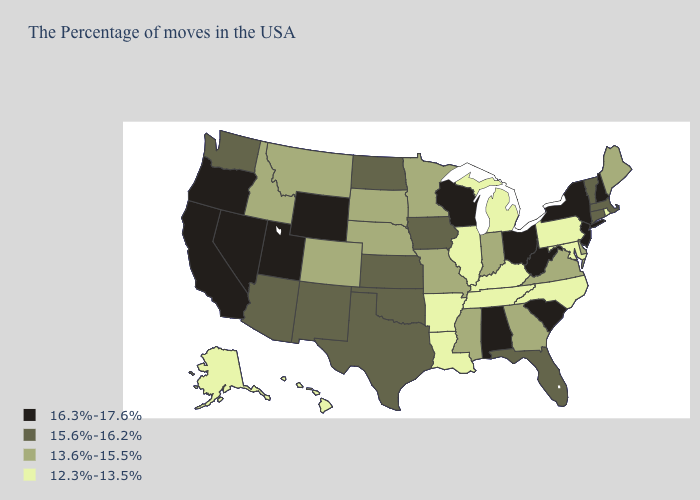What is the lowest value in states that border Maine?
Answer briefly. 16.3%-17.6%. Name the states that have a value in the range 16.3%-17.6%?
Keep it brief. New Hampshire, New York, New Jersey, South Carolina, West Virginia, Ohio, Alabama, Wisconsin, Wyoming, Utah, Nevada, California, Oregon. What is the value of Nebraska?
Keep it brief. 13.6%-15.5%. Does Utah have the highest value in the West?
Keep it brief. Yes. Name the states that have a value in the range 15.6%-16.2%?
Write a very short answer. Massachusetts, Vermont, Connecticut, Florida, Iowa, Kansas, Oklahoma, Texas, North Dakota, New Mexico, Arizona, Washington. Does Indiana have the lowest value in the MidWest?
Concise answer only. No. What is the value of Wyoming?
Write a very short answer. 16.3%-17.6%. Does the first symbol in the legend represent the smallest category?
Concise answer only. No. How many symbols are there in the legend?
Concise answer only. 4. Name the states that have a value in the range 12.3%-13.5%?
Short answer required. Rhode Island, Maryland, Pennsylvania, North Carolina, Michigan, Kentucky, Tennessee, Illinois, Louisiana, Arkansas, Alaska, Hawaii. What is the value of Rhode Island?
Write a very short answer. 12.3%-13.5%. Name the states that have a value in the range 16.3%-17.6%?
Quick response, please. New Hampshire, New York, New Jersey, South Carolina, West Virginia, Ohio, Alabama, Wisconsin, Wyoming, Utah, Nevada, California, Oregon. Among the states that border New Hampshire , does Maine have the highest value?
Short answer required. No. Among the states that border Minnesota , does Wisconsin have the highest value?
Answer briefly. Yes. Among the states that border Arkansas , which have the highest value?
Concise answer only. Oklahoma, Texas. 